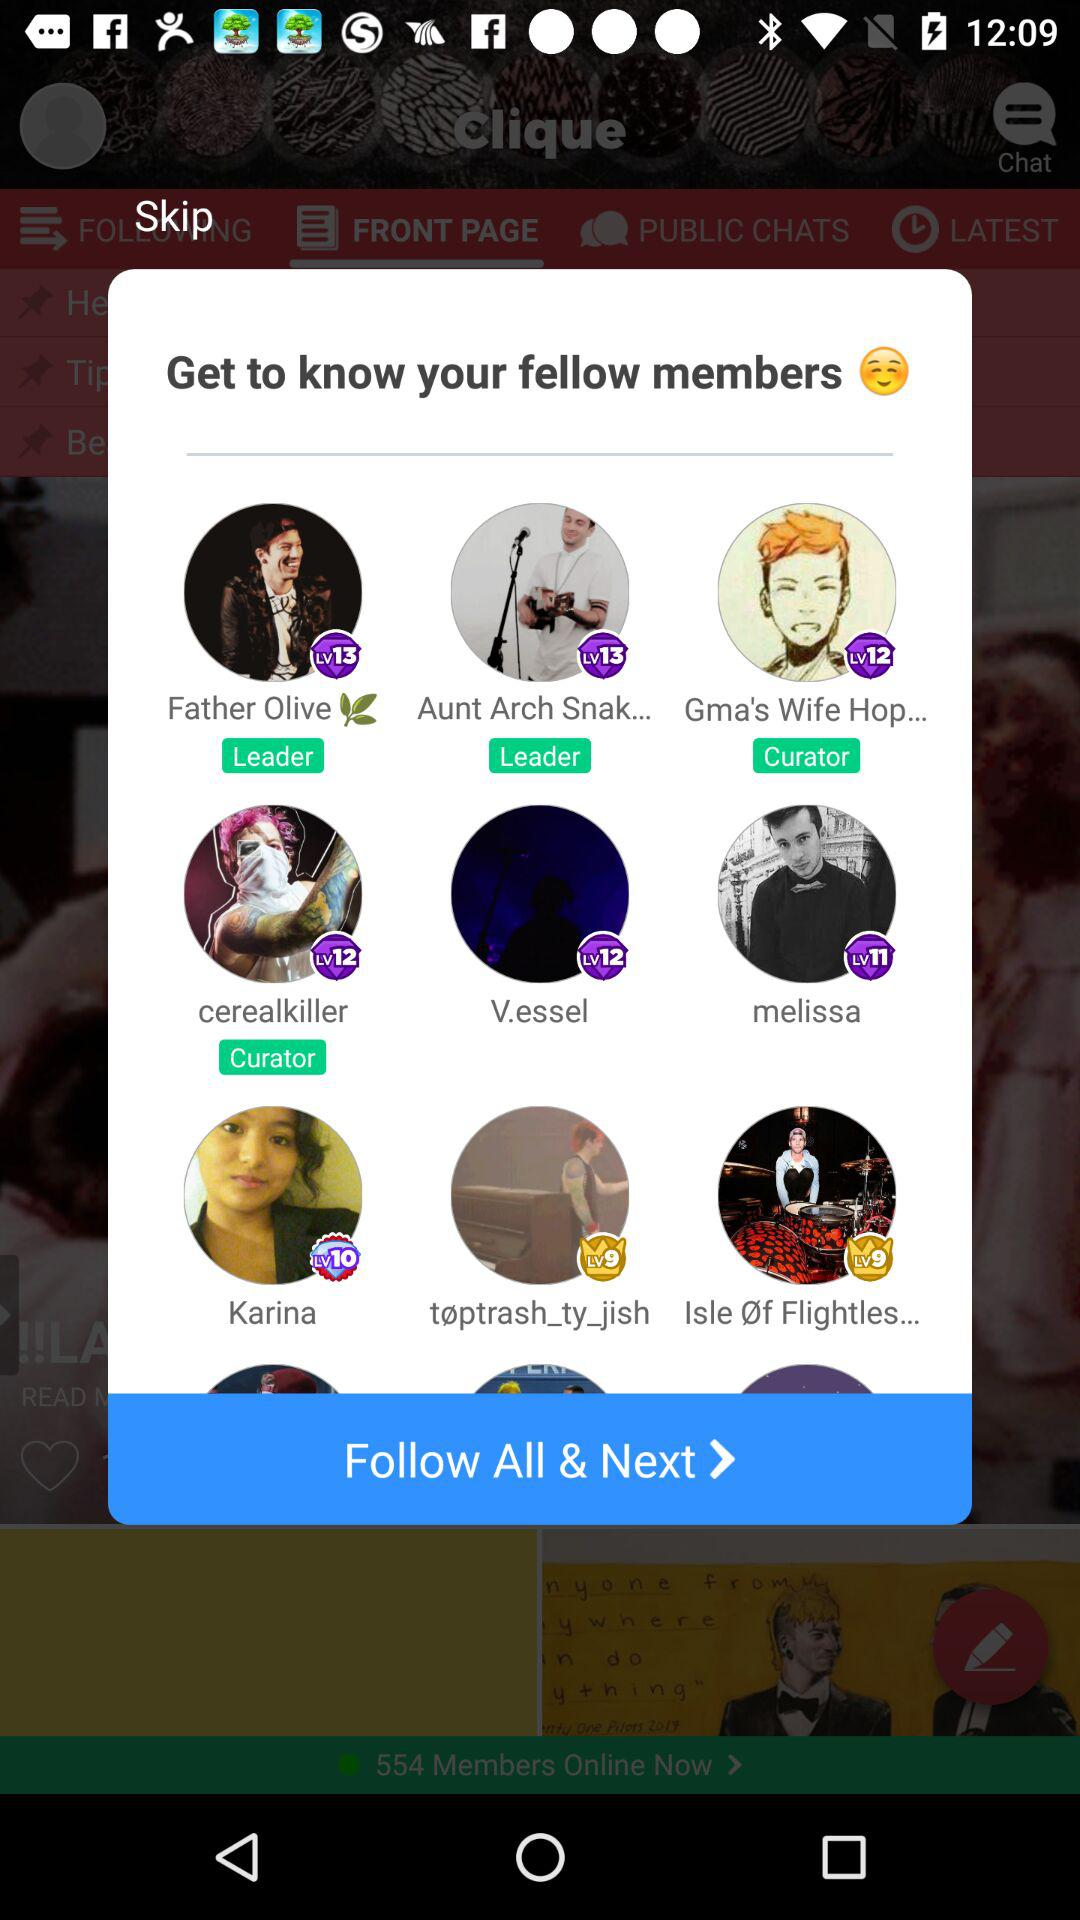What is the role of "cerealkiller"? The role of "cerealkiller" is curator. 